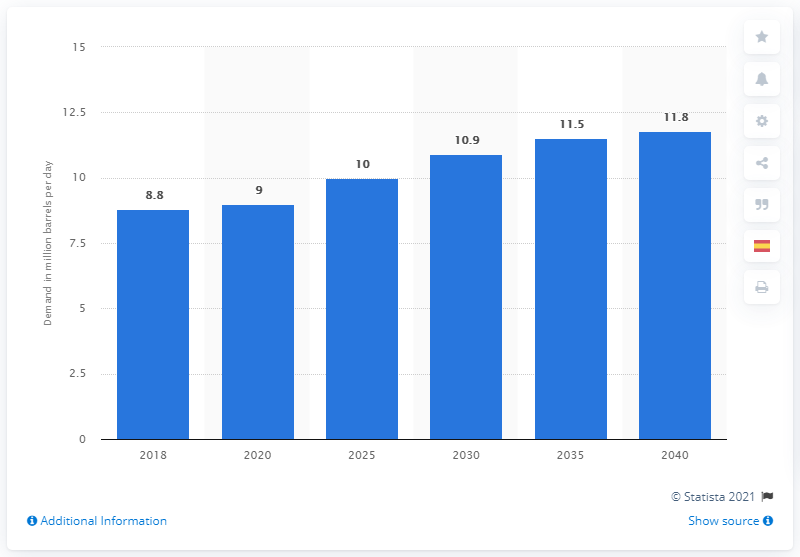Mention a couple of crucial points in this snapshot. In 2018, the demand for crude oil among the member countries of the Organization of the Petroleum Exporting Countries (OPEC) was approximately 8.8 million barrels per day. The expected increase in crude oil demand among OPEC member countries in 2040 is projected to be 11.8%. 